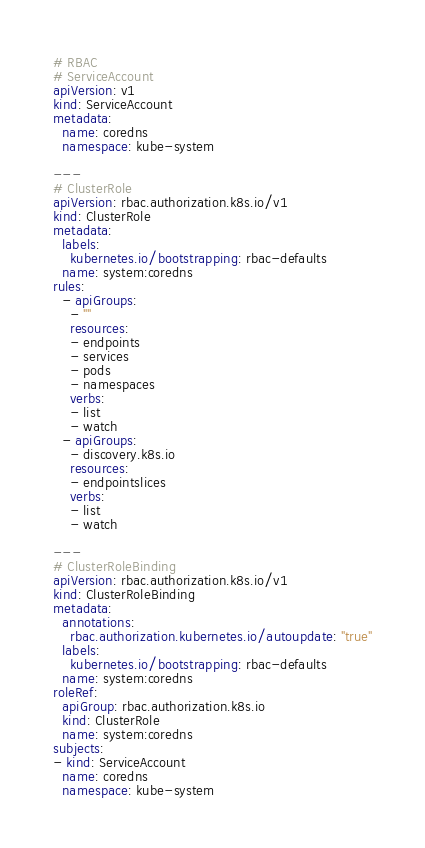Convert code to text. <code><loc_0><loc_0><loc_500><loc_500><_YAML_># RBAC
# ServiceAccount
apiVersion: v1
kind: ServiceAccount
metadata:
  name: coredns
  namespace: kube-system

---
# ClusterRole
apiVersion: rbac.authorization.k8s.io/v1
kind: ClusterRole
metadata:
  labels:
    kubernetes.io/bootstrapping: rbac-defaults
  name: system:coredns
rules:
  - apiGroups:
    - ""
    resources:
    - endpoints
    - services
    - pods
    - namespaces
    verbs:
    - list
    - watch
  - apiGroups:
    - discovery.k8s.io
    resources:
    - endpointslices
    verbs:
    - list
    - watch

---
# ClusterRoleBinding
apiVersion: rbac.authorization.k8s.io/v1
kind: ClusterRoleBinding
metadata:
  annotations:
    rbac.authorization.kubernetes.io/autoupdate: "true"
  labels:
    kubernetes.io/bootstrapping: rbac-defaults
  name: system:coredns
roleRef:
  apiGroup: rbac.authorization.k8s.io
  kind: ClusterRole
  name: system:coredns
subjects:
- kind: ServiceAccount
  name: coredns
  namespace: kube-system
</code> 